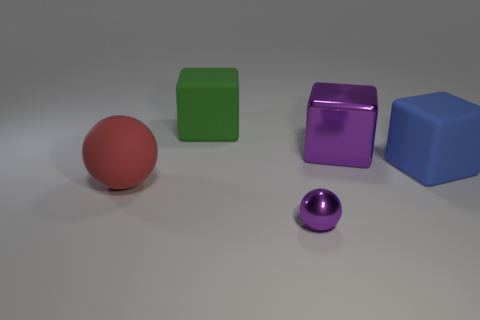Subtract all purple cubes. How many cubes are left? 2 Add 2 purple spheres. How many objects exist? 7 Subtract 1 blocks. How many blocks are left? 2 Subtract all cubes. How many objects are left? 2 Subtract all gray blocks. Subtract all brown cylinders. How many blocks are left? 3 Add 4 big green matte objects. How many big green matte objects exist? 5 Subtract 0 green spheres. How many objects are left? 5 Subtract all purple rubber cubes. Subtract all metal balls. How many objects are left? 4 Add 1 green things. How many green things are left? 2 